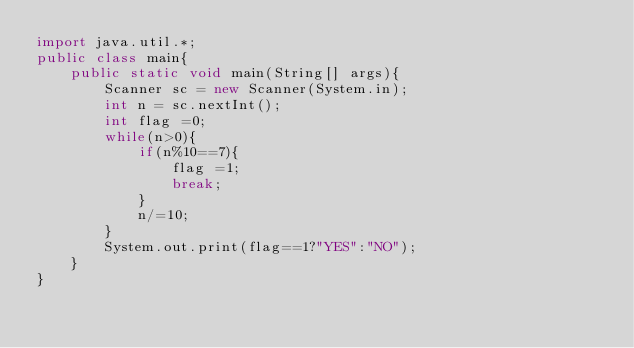Convert code to text. <code><loc_0><loc_0><loc_500><loc_500><_Java_>import java.util.*;
public class main{ 
    public static void main(String[] args){
        Scanner sc = new Scanner(System.in); 
        int n = sc.nextInt();
        int flag =0;
        while(n>0){
            if(n%10==7){
                flag =1;
                break;
            }
            n/=10;
        }
        System.out.print(flag==1?"YES":"NO");
    }
}

</code> 